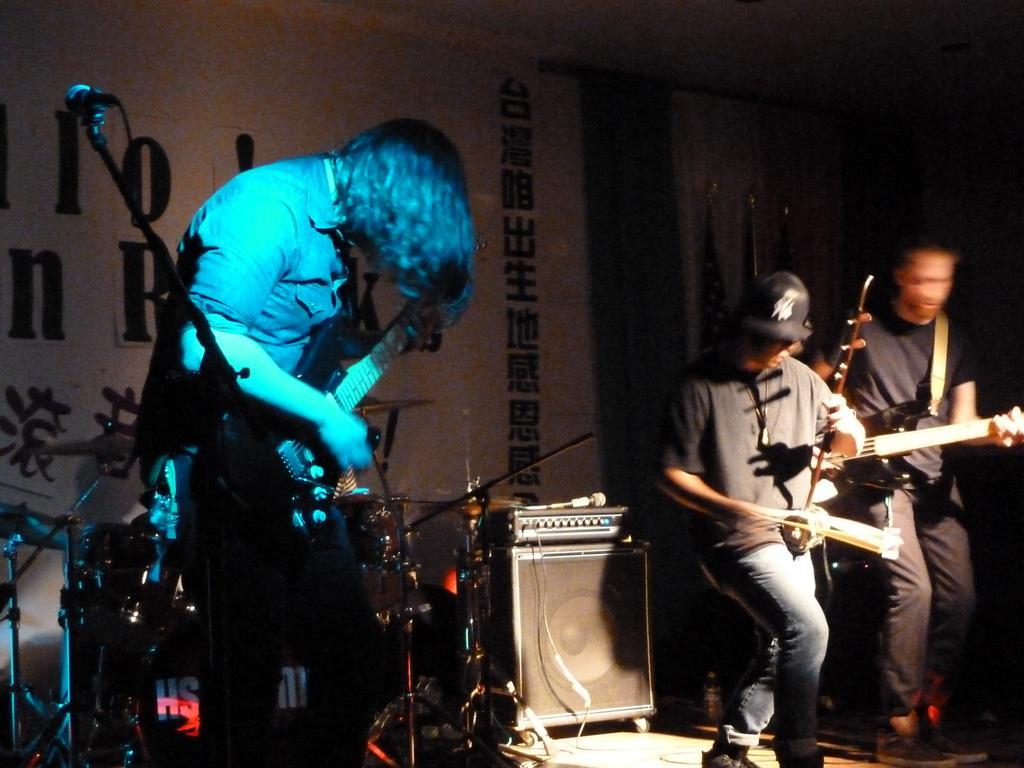Please provide a concise description of this image. In this image I can see three people and these three people are playing musical instrument. At the back there is a banner and the flags. 